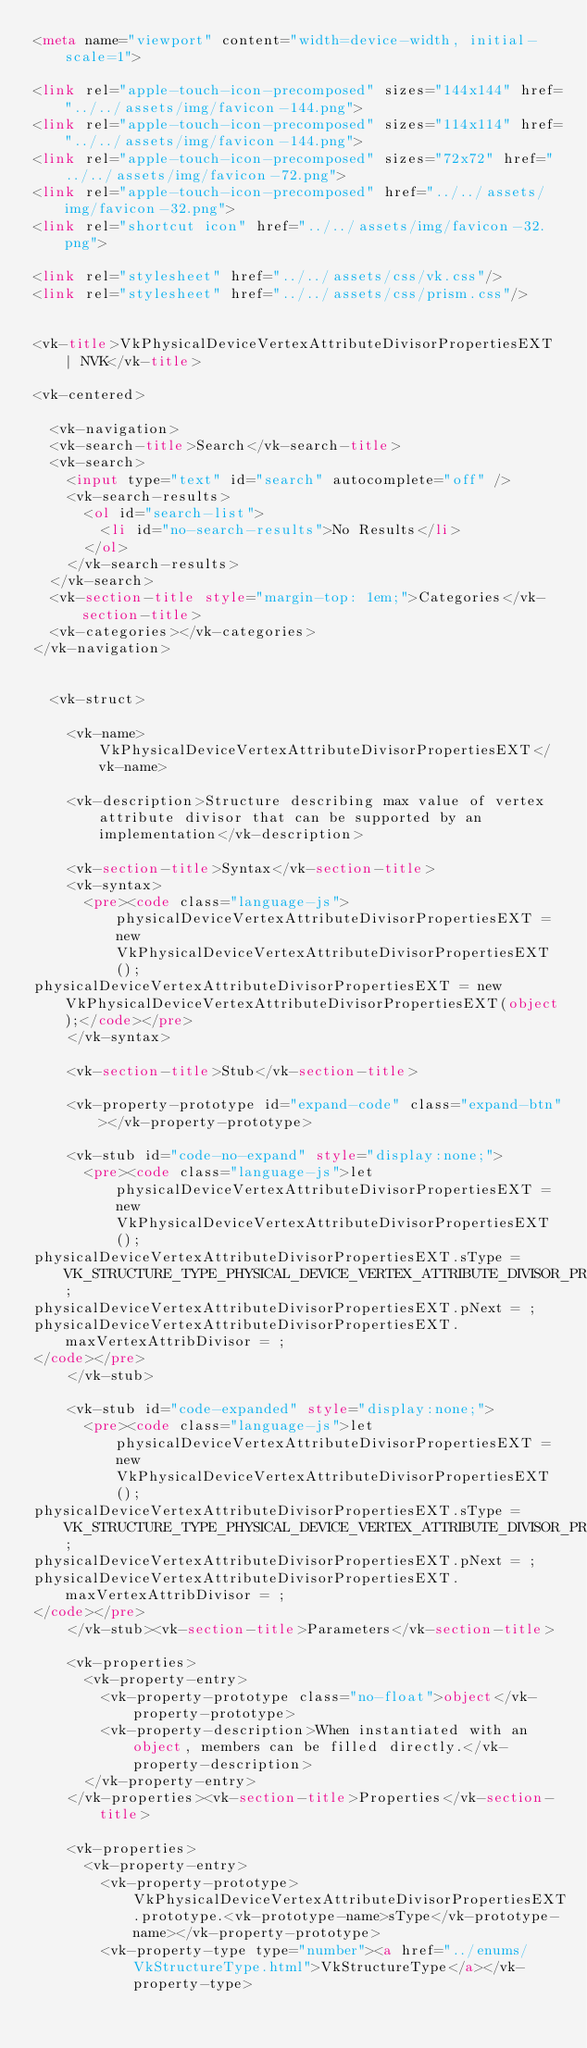<code> <loc_0><loc_0><loc_500><loc_500><_HTML_><meta name="viewport" content="width=device-width, initial-scale=1">

<link rel="apple-touch-icon-precomposed" sizes="144x144" href="../../assets/img/favicon-144.png">
<link rel="apple-touch-icon-precomposed" sizes="114x114" href="../../assets/img/favicon-144.png">
<link rel="apple-touch-icon-precomposed" sizes="72x72" href="../../assets/img/favicon-72.png">
<link rel="apple-touch-icon-precomposed" href="../../assets/img/favicon-32.png">
<link rel="shortcut icon" href="../../assets/img/favicon-32.png">

<link rel="stylesheet" href="../../assets/css/vk.css"/>
<link rel="stylesheet" href="../../assets/css/prism.css"/>


<vk-title>VkPhysicalDeviceVertexAttributeDivisorPropertiesEXT | NVK</vk-title>

<vk-centered>

  <vk-navigation>
  <vk-search-title>Search</vk-search-title>
  <vk-search>
    <input type="text" id="search" autocomplete="off" />
    <vk-search-results>
      <ol id="search-list">
        <li id="no-search-results">No Results</li>
      </ol>
    </vk-search-results>
  </vk-search>
  <vk-section-title style="margin-top: 1em;">Categories</vk-section-title>
  <vk-categories></vk-categories>
</vk-navigation>


  <vk-struct>

    <vk-name>VkPhysicalDeviceVertexAttributeDivisorPropertiesEXT</vk-name>

    <vk-description>Structure describing max value of vertex attribute divisor that can be supported by an implementation</vk-description>

    <vk-section-title>Syntax</vk-section-title>
    <vk-syntax>
      <pre><code class="language-js">physicalDeviceVertexAttributeDivisorPropertiesEXT = new VkPhysicalDeviceVertexAttributeDivisorPropertiesEXT();
physicalDeviceVertexAttributeDivisorPropertiesEXT = new VkPhysicalDeviceVertexAttributeDivisorPropertiesEXT(object);</code></pre>
    </vk-syntax>

    <vk-section-title>Stub</vk-section-title>
    
    <vk-property-prototype id="expand-code" class="expand-btn"></vk-property-prototype>

    <vk-stub id="code-no-expand" style="display:none;">
      <pre><code class="language-js">let physicalDeviceVertexAttributeDivisorPropertiesEXT = new VkPhysicalDeviceVertexAttributeDivisorPropertiesEXT();
physicalDeviceVertexAttributeDivisorPropertiesEXT.sType = VK_STRUCTURE_TYPE_PHYSICAL_DEVICE_VERTEX_ATTRIBUTE_DIVISOR_PROPERTIES_EXT;
physicalDeviceVertexAttributeDivisorPropertiesEXT.pNext = ;
physicalDeviceVertexAttributeDivisorPropertiesEXT.maxVertexAttribDivisor = ;
</code></pre>
    </vk-stub>

    <vk-stub id="code-expanded" style="display:none;">
      <pre><code class="language-js">let physicalDeviceVertexAttributeDivisorPropertiesEXT = new VkPhysicalDeviceVertexAttributeDivisorPropertiesEXT();
physicalDeviceVertexAttributeDivisorPropertiesEXT.sType = VK_STRUCTURE_TYPE_PHYSICAL_DEVICE_VERTEX_ATTRIBUTE_DIVISOR_PROPERTIES_EXT;
physicalDeviceVertexAttributeDivisorPropertiesEXT.pNext = ;
physicalDeviceVertexAttributeDivisorPropertiesEXT.maxVertexAttribDivisor = ;
</code></pre>
    </vk-stub><vk-section-title>Parameters</vk-section-title>

    <vk-properties>
      <vk-property-entry>
        <vk-property-prototype class="no-float">object</vk-property-prototype>
        <vk-property-description>When instantiated with an object, members can be filled directly.</vk-property-description>
      </vk-property-entry>
    </vk-properties><vk-section-title>Properties</vk-section-title>

    <vk-properties>
      <vk-property-entry>
        <vk-property-prototype>VkPhysicalDeviceVertexAttributeDivisorPropertiesEXT.prototype.<vk-prototype-name>sType</vk-prototype-name></vk-property-prototype>
        <vk-property-type type="number"><a href="../enums/VkStructureType.html">VkStructureType</a></vk-property-type></code> 